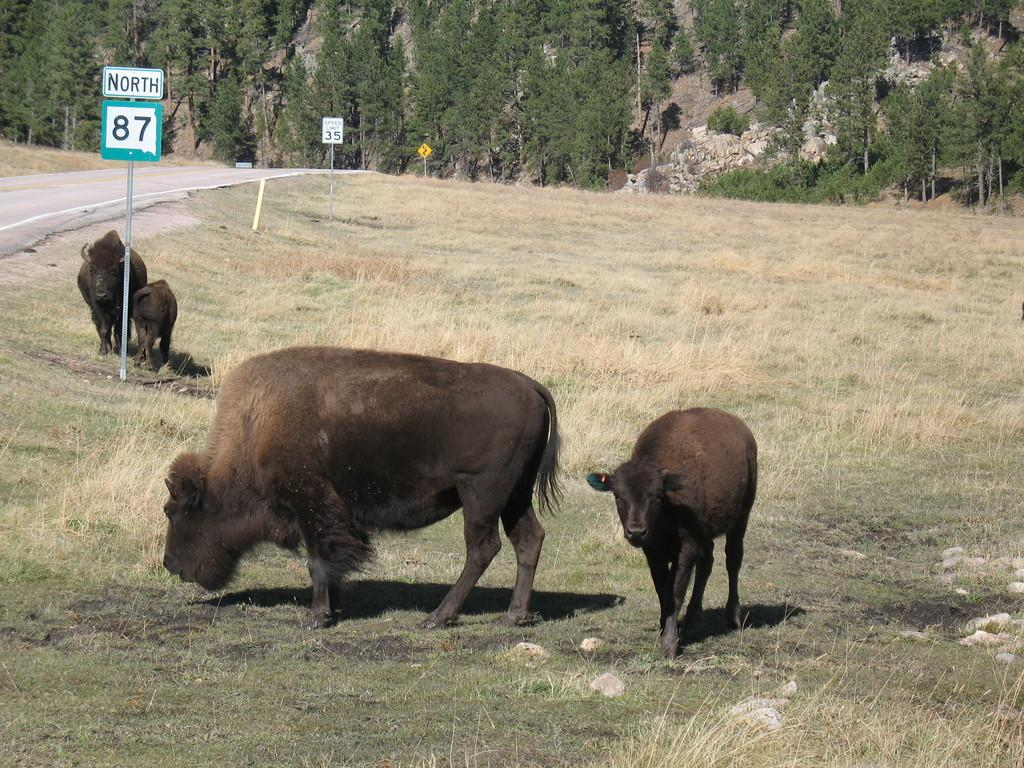What animals are present in the image? There are buffaloes in the image. What are the buffaloes doing in the image? The buffaloes are walking on the ground. What type of vegetation is visible at the bottom of the image? There is grass at the bottom of the image. What can be seen in the background of the image? There are plants and trees in the background of the image. What architectural feature is visible to the left of the image? There is a road to the left of the image. What type of silver relation can be seen between the buffaloes in the image? There is no silver relation or any silver objects present in the image. The image features buffaloes walking on the ground and their interactions are not related to silver. 